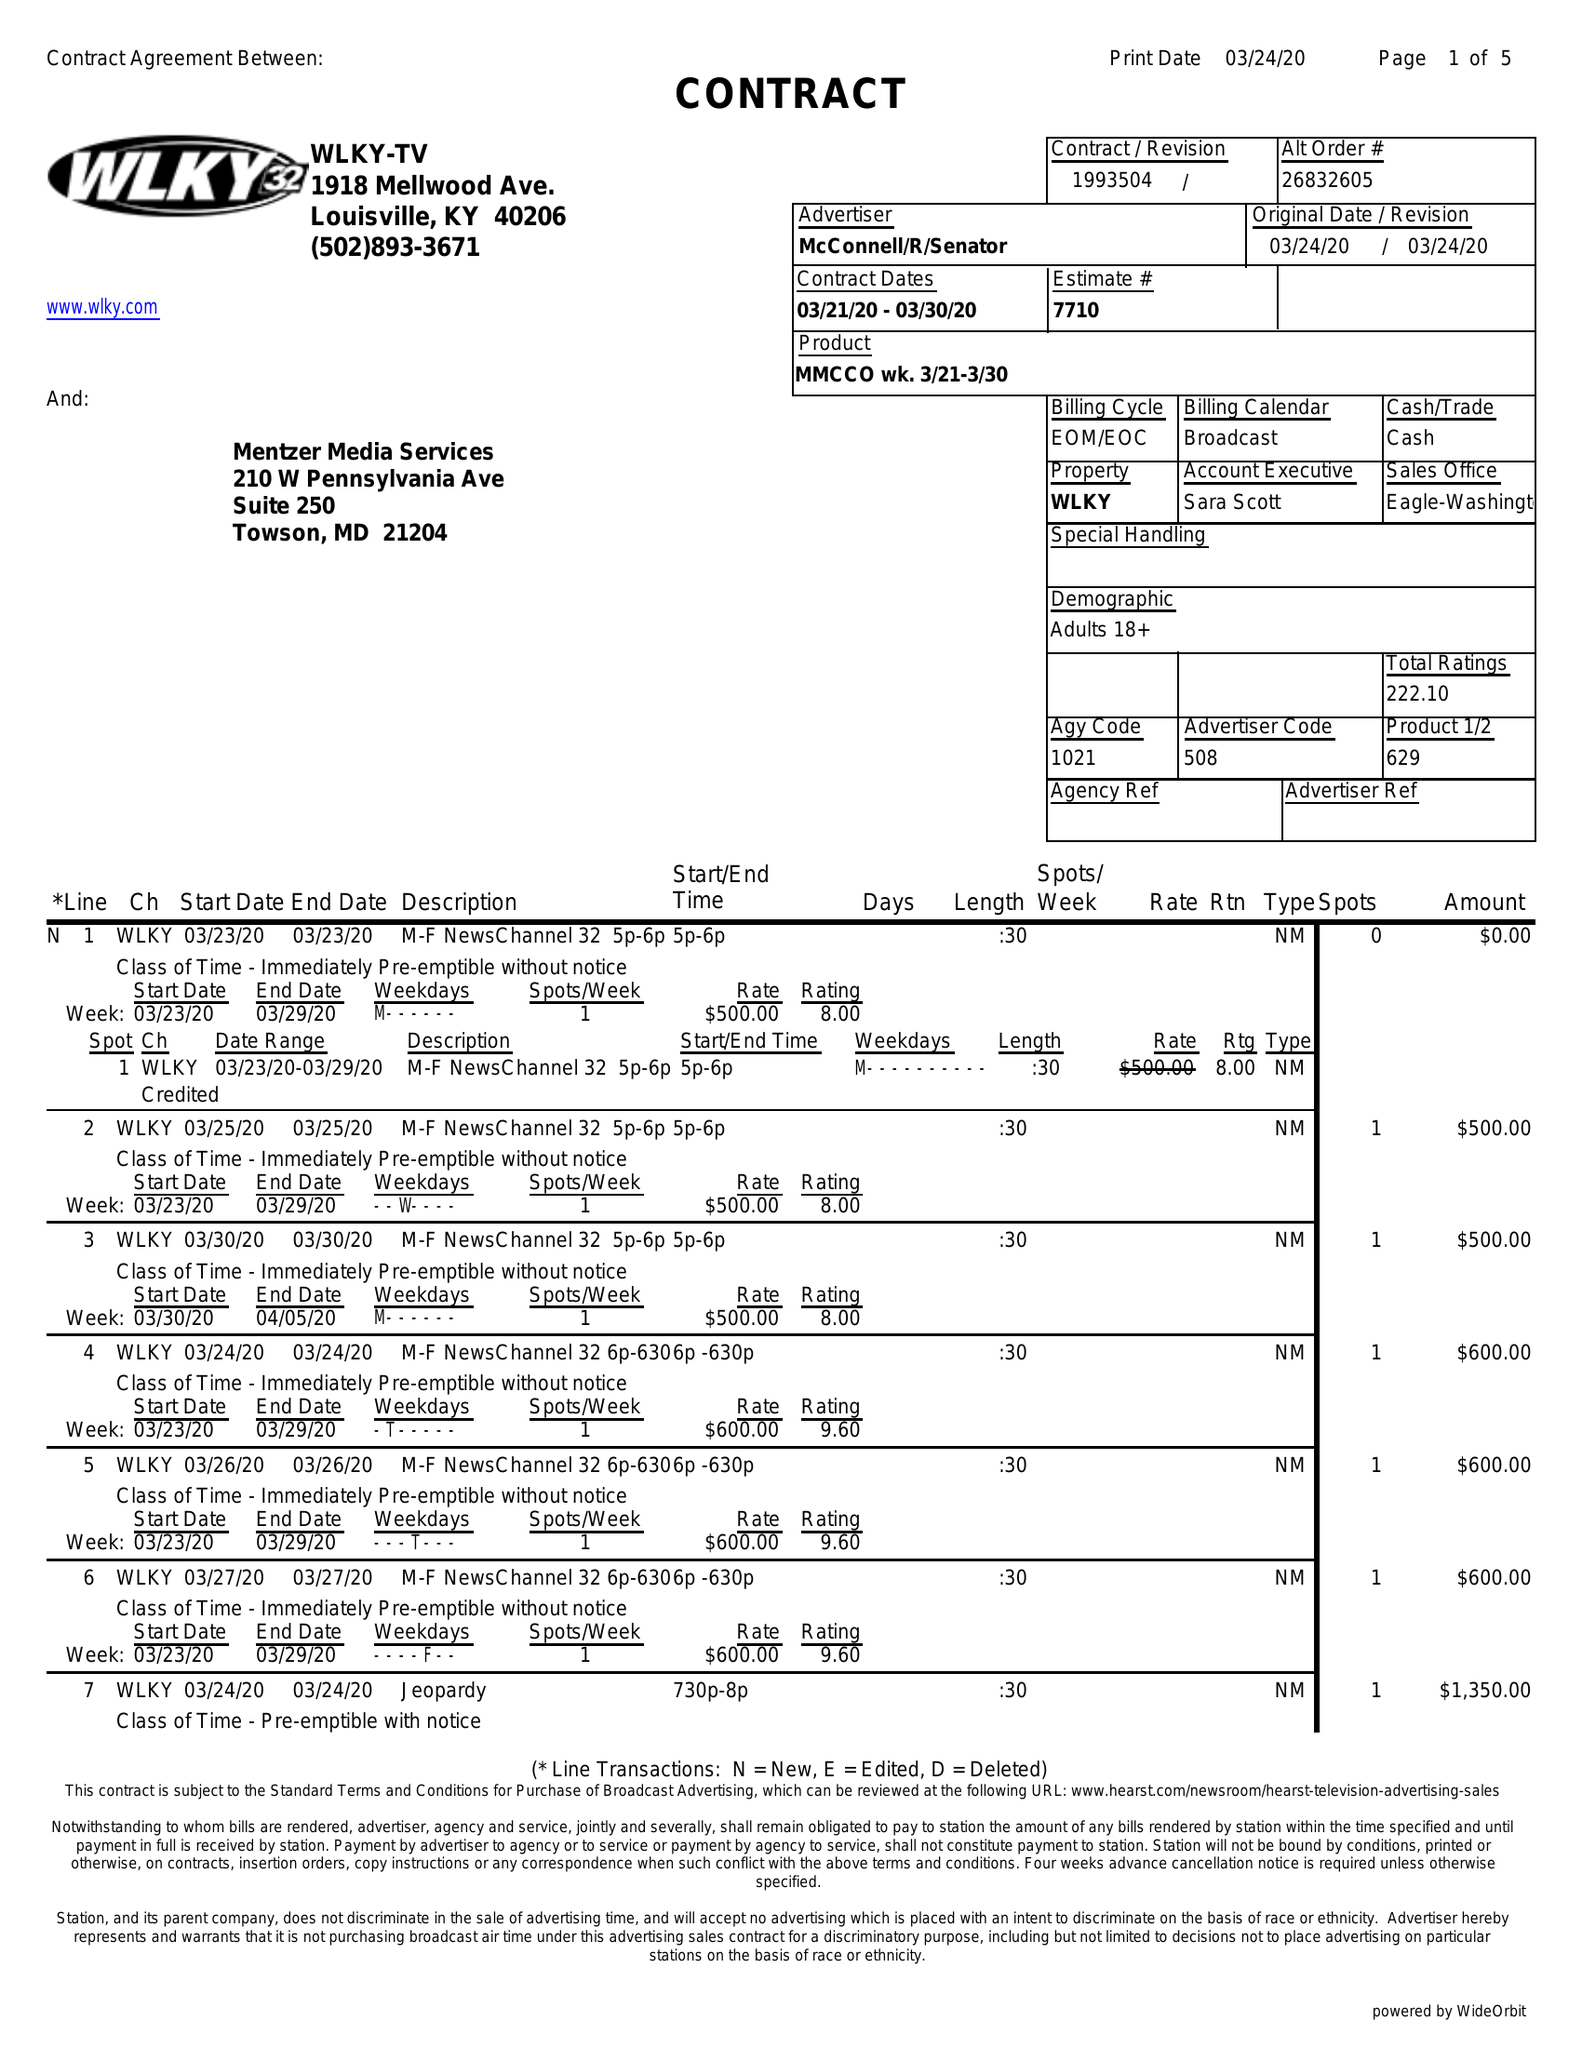What is the value for the gross_amount?
Answer the question using a single word or phrase. 24150.00 